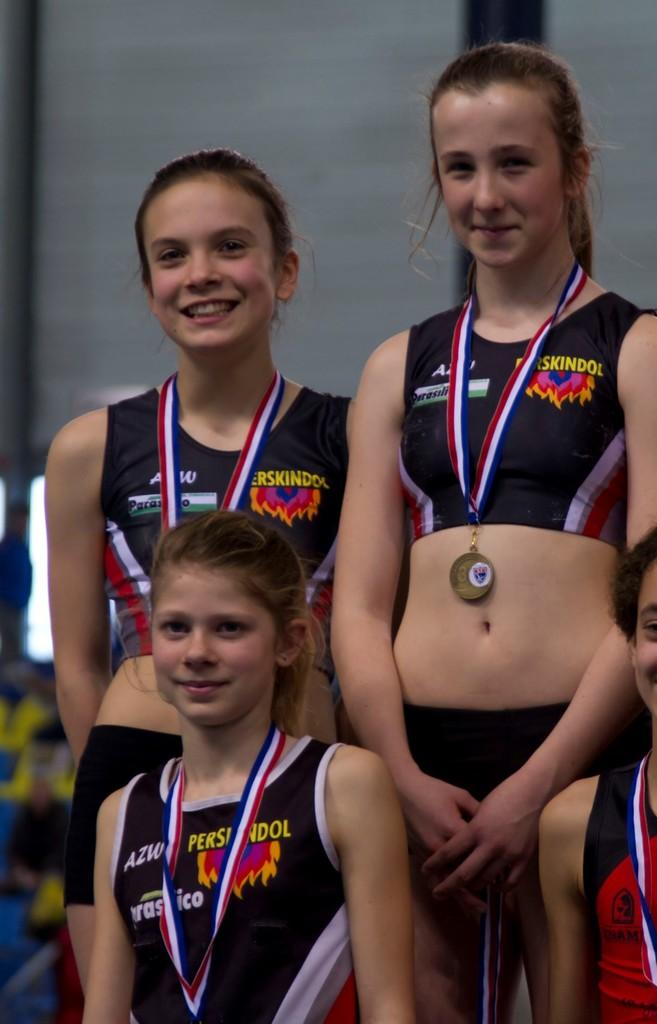<image>
Summarize the visual content of the image. three girls with perskindol tanks tops are wearing medals 